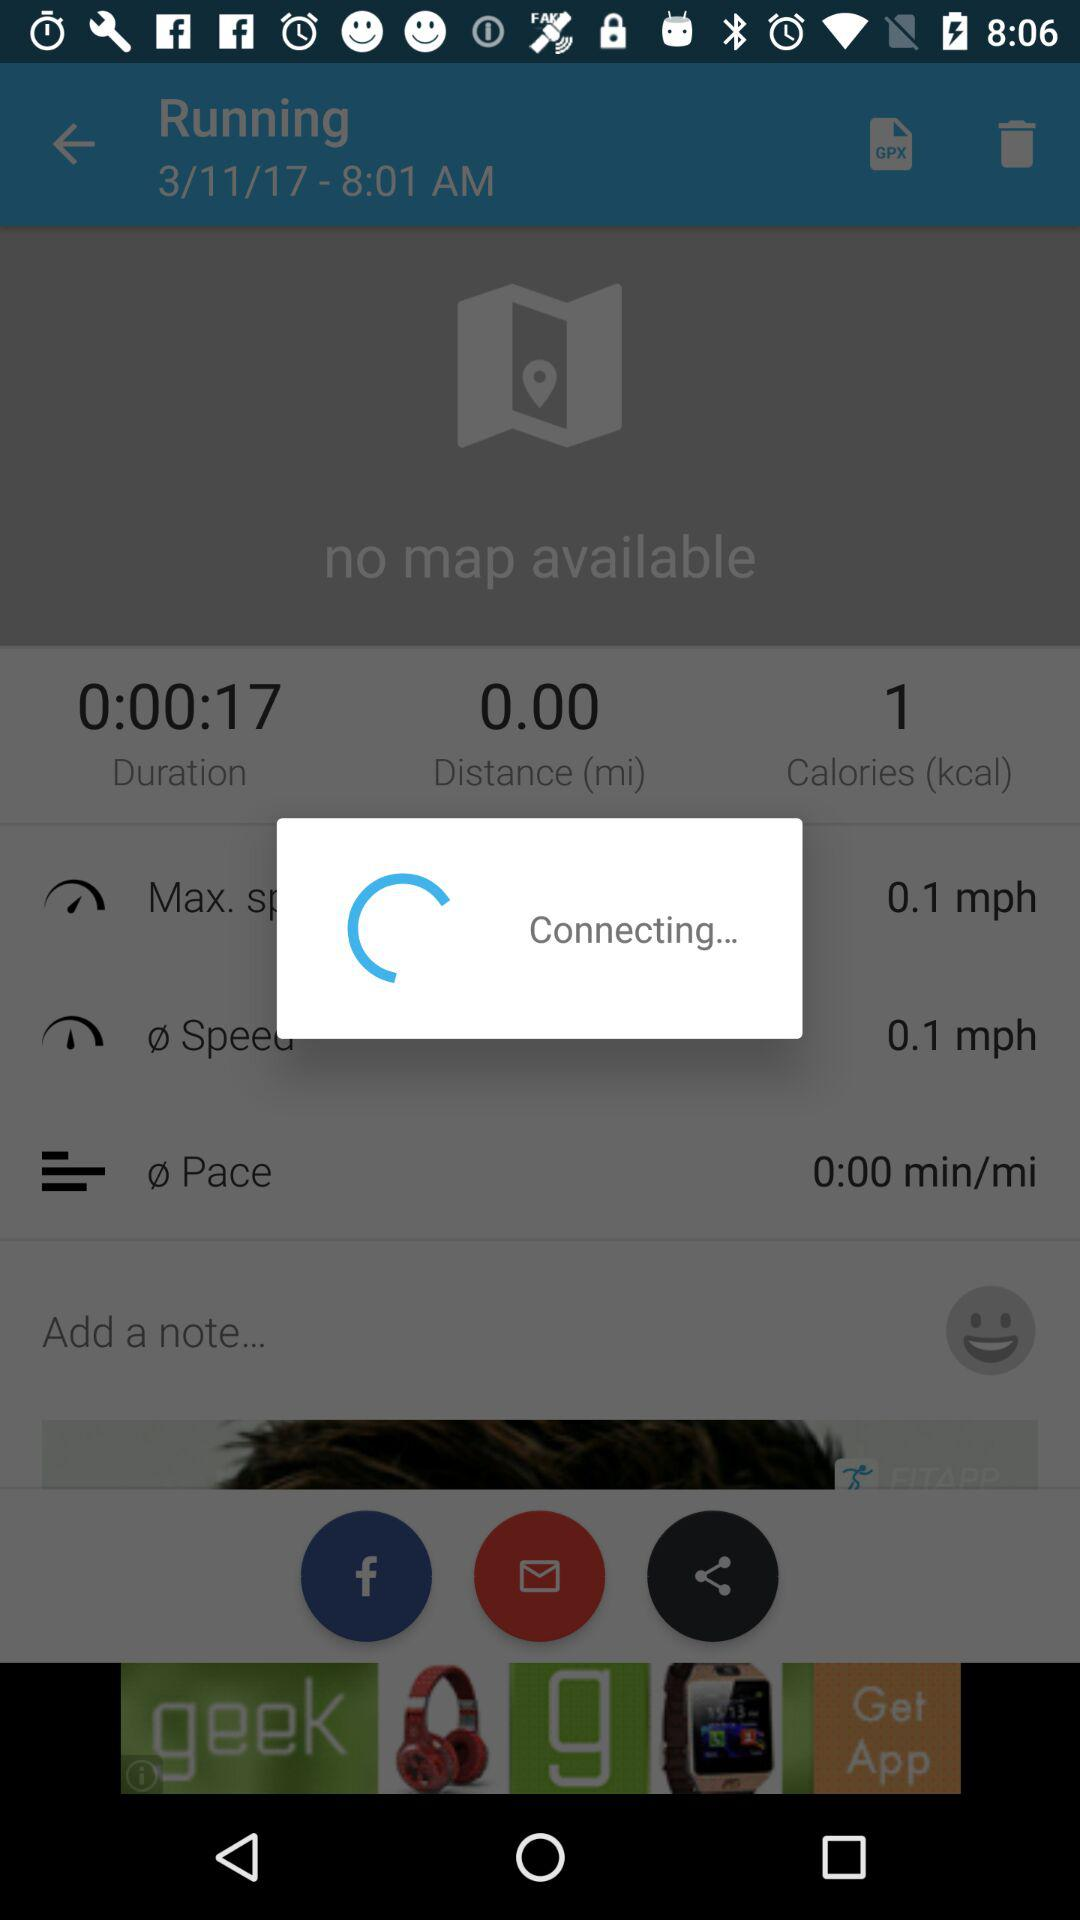What is the distance? The distance is 0.00 miles. 